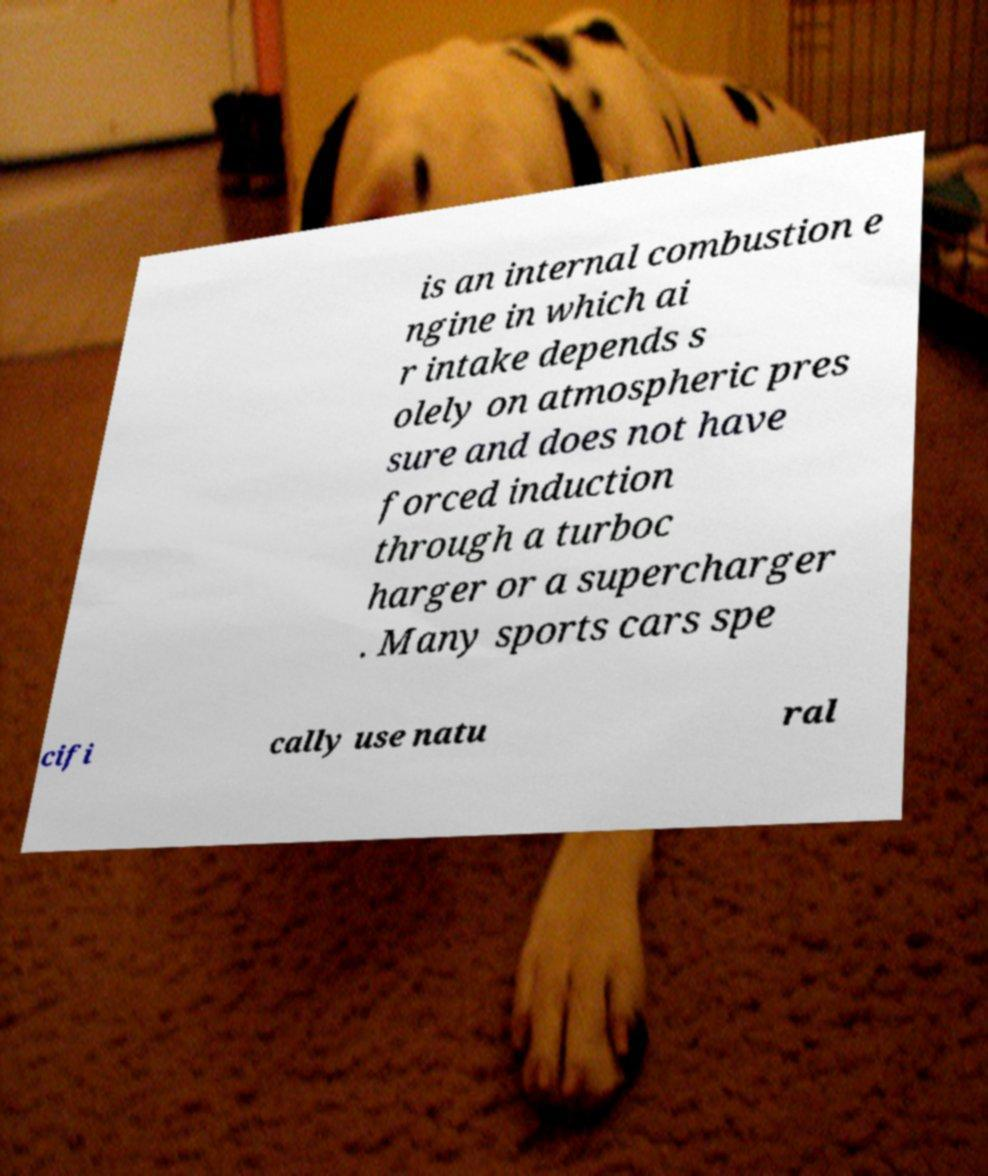What messages or text are displayed in this image? I need them in a readable, typed format. is an internal combustion e ngine in which ai r intake depends s olely on atmospheric pres sure and does not have forced induction through a turboc harger or a supercharger . Many sports cars spe cifi cally use natu ral 